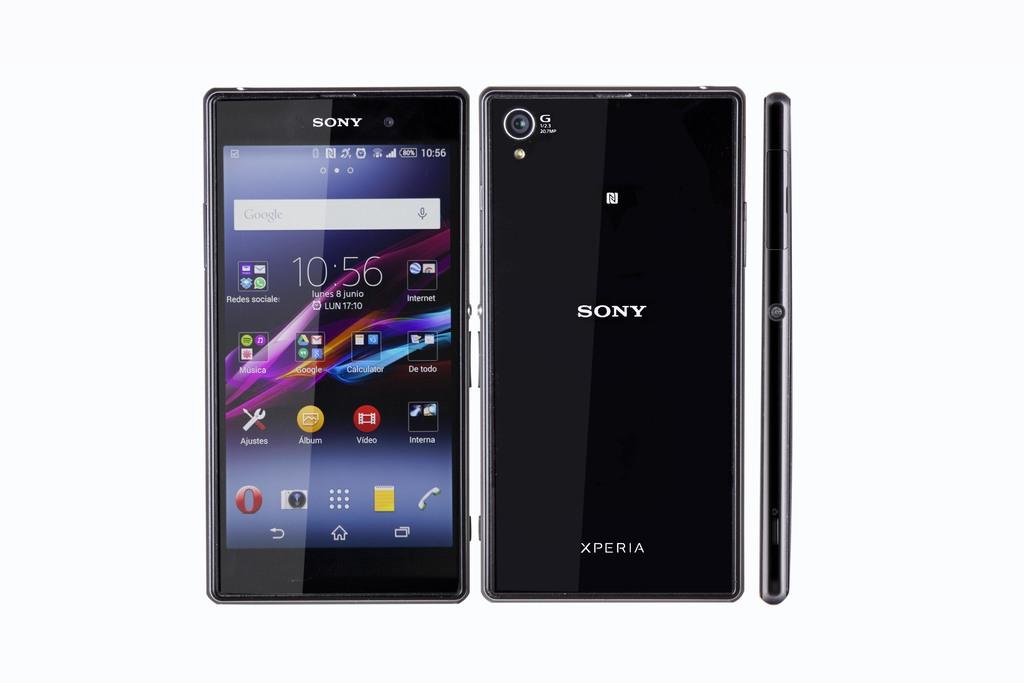What is the brand of the phone?
Make the answer very short. Sony. 